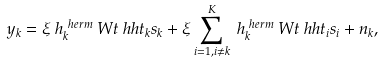Convert formula to latex. <formula><loc_0><loc_0><loc_500><loc_500>y _ { k } & = \xi \ h _ { k } ^ { \ h e r m } \ W t \ h h t _ { k } s _ { k } + \xi \sum _ { i = 1 , i \neq k } ^ { K } \ h _ { k } ^ { \ h e r m } \ W t \ h h t _ { i } s _ { i } + n _ { k } ,</formula> 